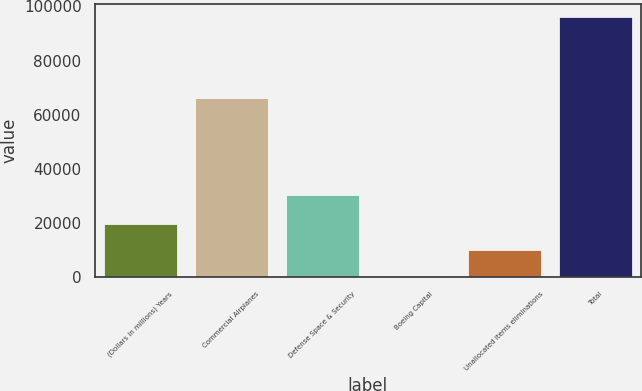Convert chart to OTSL. <chart><loc_0><loc_0><loc_500><loc_500><bar_chart><fcel>(Dollars in millions) Years<fcel>Commercial Airplanes<fcel>Defense Space & Security<fcel>Boeing Capital<fcel>Unallocated items eliminations<fcel>Total<nl><fcel>19553.2<fcel>66048<fcel>30388<fcel>413<fcel>9983.1<fcel>96114<nl></chart> 